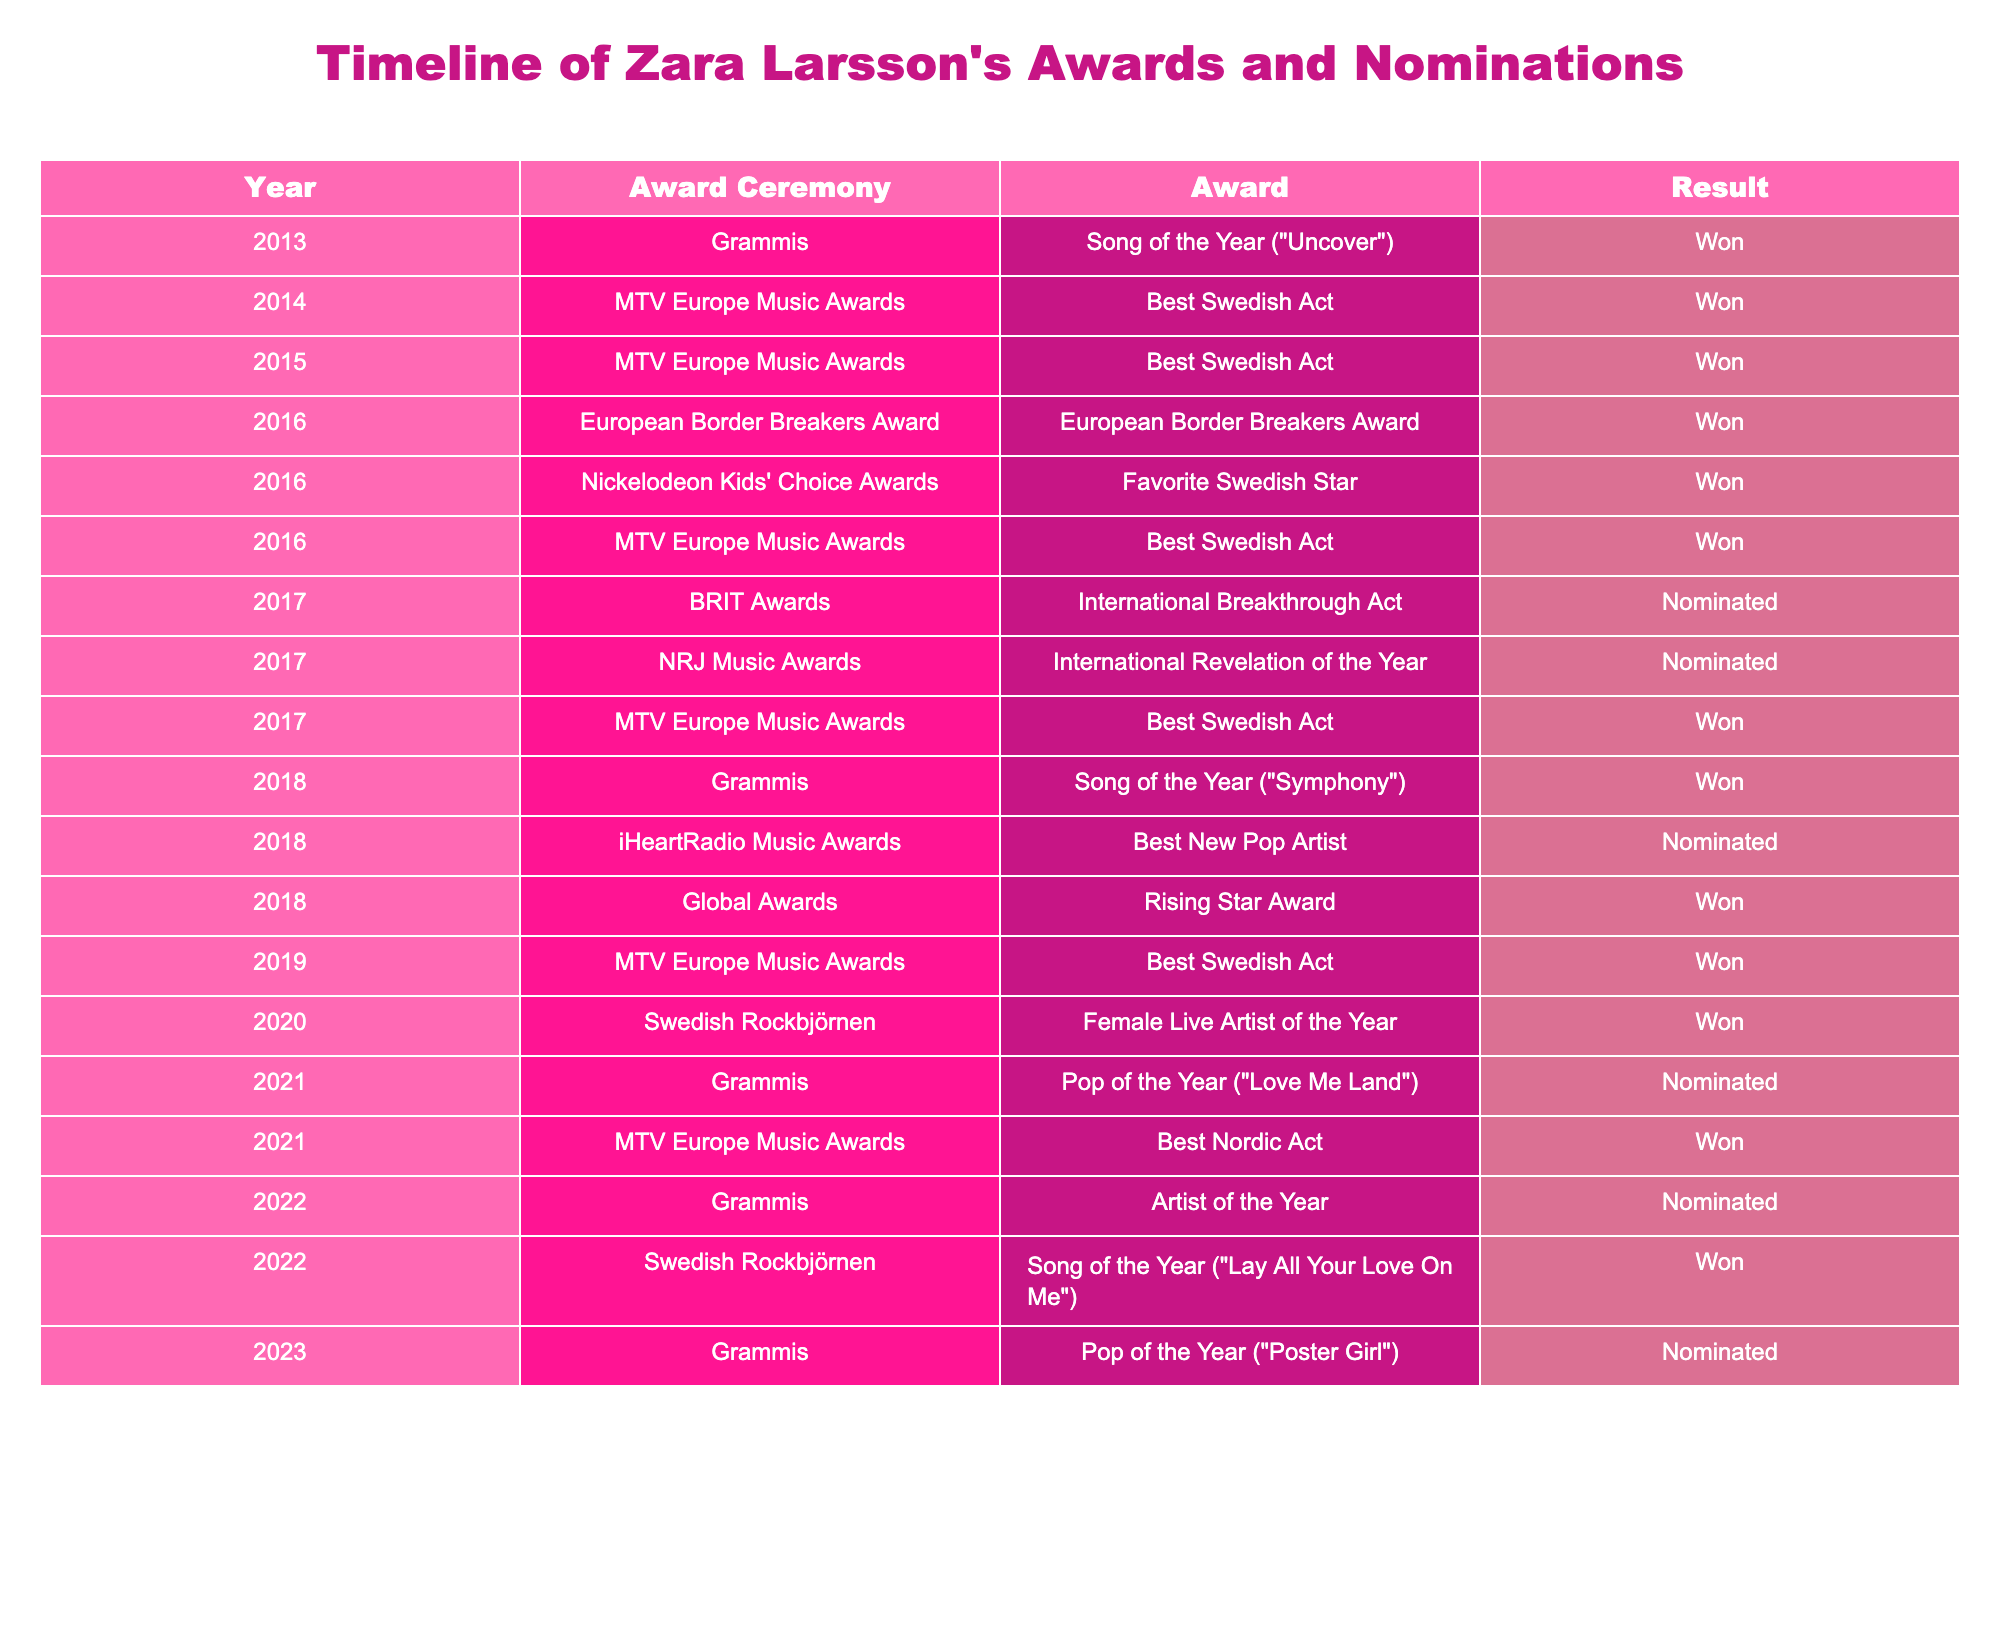What year did Zara Larsson win the Best Swedish Act at the MTV Europe Music Awards for the first time? In the table, Zara Larsson first won the Best Swedish Act at the MTV Europe Music Awards in 2014.
Answer: 2014 How many times did Zara Larsson receive nominations for the Grammis? From the table, Zara Larsson was nominated for the Grammis in 2018, 2021, and 2023, which sums up to three nominations.
Answer: 3 Did Zara Larsson win any awards in 2020? In the table, it shows that Zara Larsson won the Female Live Artist of the Year at the Swedish Rockbjörnen in 2020.
Answer: Yes What is the total number of awards Zara Larsson won and nominated for from 2016 to 2022? The wins from 2016 to 2022 are: 2016 (3 wins), 2017 (1 win), 2018 (2 wins), 2019 (1 win), 2020 (1 win), 2022 (1 win), totaling 9 wins. The nominations are: 2017 (2 nominations), 2018 (1 nomination), 2021 (1 nomination), and 2022 (1 nomination), totaling 5 nominations. Adding these gives 9 (wins) + 5 (nominations) = 14.
Answer: 14 In what year did Zara Larsson have the most wins listed in the table? Reviewing the table, the year 2016 has the highest number of wins listed, with Zara Larsson winning three awards that year.
Answer: 2016 How many awards did Zara Larsson achieve at the MTV Europe Music Awards? From the table, she won the Best Swedish Act three times (2014, 2015, and 2017), resulting in three wins at the MTV Europe Music Awards.
Answer: 3 Was Zara Larsson nominated or did she win the Artist of the Year at the Grammis in 2022? The table indicates that Zara Larsson was nominated for Artist of the Year at the Grammis in 2022, not that she won.
Answer: Nominated Which award ceremony honored Zara Larsson as the International Breakthrough Act? According to the table, Zara Larsson was nominated for the International Breakthrough Act at the BRIT Awards in 2017.
Answer: BRIT Awards 